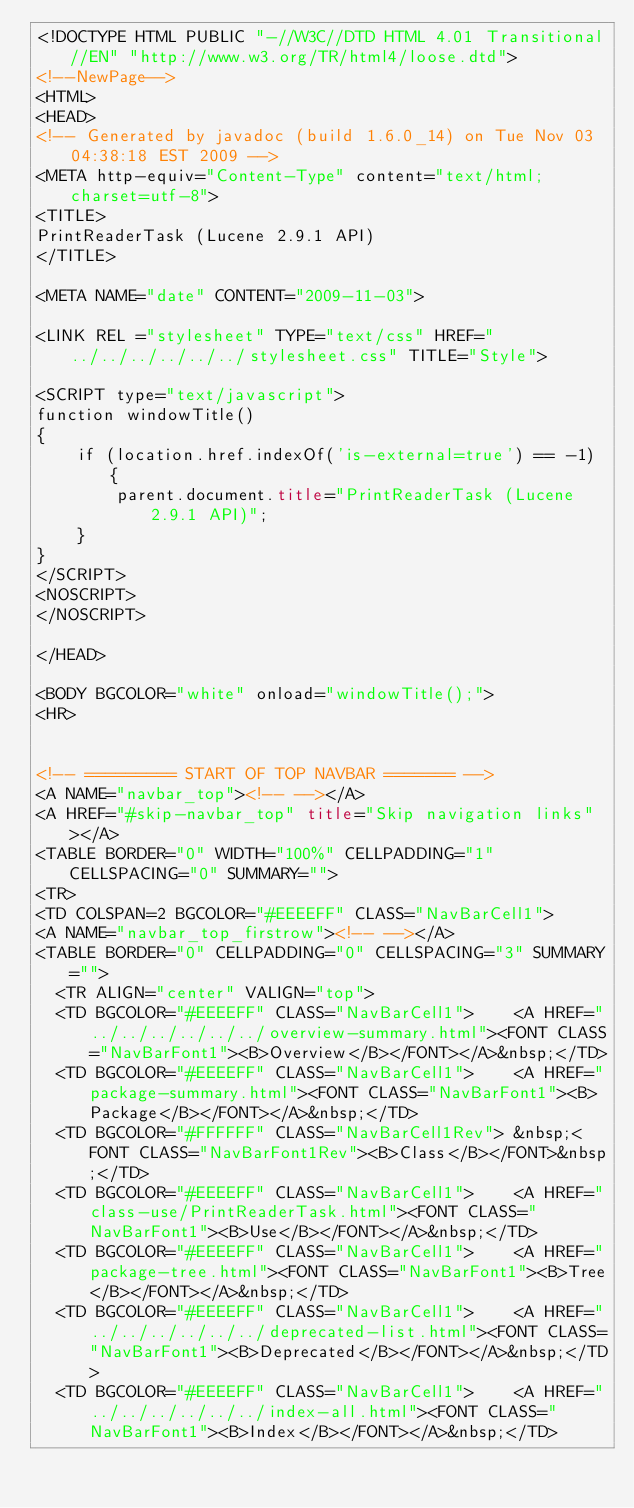Convert code to text. <code><loc_0><loc_0><loc_500><loc_500><_HTML_><!DOCTYPE HTML PUBLIC "-//W3C//DTD HTML 4.01 Transitional//EN" "http://www.w3.org/TR/html4/loose.dtd">
<!--NewPage-->
<HTML>
<HEAD>
<!-- Generated by javadoc (build 1.6.0_14) on Tue Nov 03 04:38:18 EST 2009 -->
<META http-equiv="Content-Type" content="text/html; charset=utf-8">
<TITLE>
PrintReaderTask (Lucene 2.9.1 API)
</TITLE>

<META NAME="date" CONTENT="2009-11-03">

<LINK REL ="stylesheet" TYPE="text/css" HREF="../../../../../../stylesheet.css" TITLE="Style">

<SCRIPT type="text/javascript">
function windowTitle()
{
    if (location.href.indexOf('is-external=true') == -1) {
        parent.document.title="PrintReaderTask (Lucene 2.9.1 API)";
    }
}
</SCRIPT>
<NOSCRIPT>
</NOSCRIPT>

</HEAD>

<BODY BGCOLOR="white" onload="windowTitle();">
<HR>


<!-- ========= START OF TOP NAVBAR ======= -->
<A NAME="navbar_top"><!-- --></A>
<A HREF="#skip-navbar_top" title="Skip navigation links"></A>
<TABLE BORDER="0" WIDTH="100%" CELLPADDING="1" CELLSPACING="0" SUMMARY="">
<TR>
<TD COLSPAN=2 BGCOLOR="#EEEEFF" CLASS="NavBarCell1">
<A NAME="navbar_top_firstrow"><!-- --></A>
<TABLE BORDER="0" CELLPADDING="0" CELLSPACING="3" SUMMARY="">
  <TR ALIGN="center" VALIGN="top">
  <TD BGCOLOR="#EEEEFF" CLASS="NavBarCell1">    <A HREF="../../../../../../overview-summary.html"><FONT CLASS="NavBarFont1"><B>Overview</B></FONT></A>&nbsp;</TD>
  <TD BGCOLOR="#EEEEFF" CLASS="NavBarCell1">    <A HREF="package-summary.html"><FONT CLASS="NavBarFont1"><B>Package</B></FONT></A>&nbsp;</TD>
  <TD BGCOLOR="#FFFFFF" CLASS="NavBarCell1Rev"> &nbsp;<FONT CLASS="NavBarFont1Rev"><B>Class</B></FONT>&nbsp;</TD>
  <TD BGCOLOR="#EEEEFF" CLASS="NavBarCell1">    <A HREF="class-use/PrintReaderTask.html"><FONT CLASS="NavBarFont1"><B>Use</B></FONT></A>&nbsp;</TD>
  <TD BGCOLOR="#EEEEFF" CLASS="NavBarCell1">    <A HREF="package-tree.html"><FONT CLASS="NavBarFont1"><B>Tree</B></FONT></A>&nbsp;</TD>
  <TD BGCOLOR="#EEEEFF" CLASS="NavBarCell1">    <A HREF="../../../../../../deprecated-list.html"><FONT CLASS="NavBarFont1"><B>Deprecated</B></FONT></A>&nbsp;</TD>
  <TD BGCOLOR="#EEEEFF" CLASS="NavBarCell1">    <A HREF="../../../../../../index-all.html"><FONT CLASS="NavBarFont1"><B>Index</B></FONT></A>&nbsp;</TD></code> 